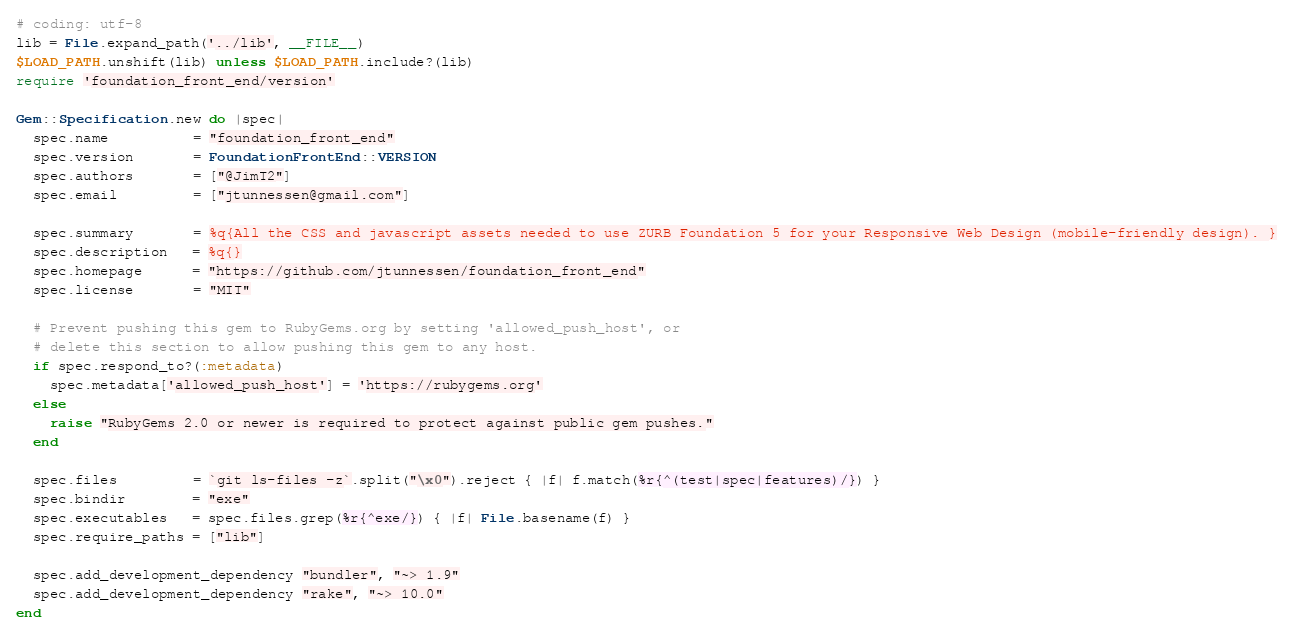<code> <loc_0><loc_0><loc_500><loc_500><_Ruby_># coding: utf-8
lib = File.expand_path('../lib', __FILE__)
$LOAD_PATH.unshift(lib) unless $LOAD_PATH.include?(lib)
require 'foundation_front_end/version'

Gem::Specification.new do |spec|
  spec.name          = "foundation_front_end"
  spec.version       = FoundationFrontEnd::VERSION
  spec.authors       = ["@JimT2"]
  spec.email         = ["jtunnessen@gmail.com"]

  spec.summary       = %q{All the CSS and javascript assets needed to use ZURB Foundation 5 for your Responsive Web Design (mobile-friendly design). }
  spec.description   = %q{}
  spec.homepage      = "https://github.com/jtunnessen/foundation_front_end"
  spec.license       = "MIT"

  # Prevent pushing this gem to RubyGems.org by setting 'allowed_push_host', or
  # delete this section to allow pushing this gem to any host.
  if spec.respond_to?(:metadata)
    spec.metadata['allowed_push_host'] = 'https://rubygems.org'
  else
    raise "RubyGems 2.0 or newer is required to protect against public gem pushes."
  end

  spec.files         = `git ls-files -z`.split("\x0").reject { |f| f.match(%r{^(test|spec|features)/}) }
  spec.bindir        = "exe"
  spec.executables   = spec.files.grep(%r{^exe/}) { |f| File.basename(f) }
  spec.require_paths = ["lib"]

  spec.add_development_dependency "bundler", "~> 1.9"
  spec.add_development_dependency "rake", "~> 10.0"
end
</code> 